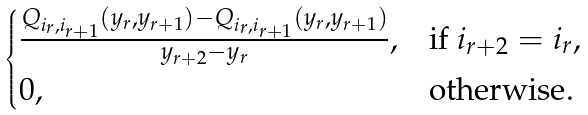Convert formula to latex. <formula><loc_0><loc_0><loc_500><loc_500>\begin{cases} \frac { Q _ { i _ { r } , i _ { r + 1 } } ( y _ { r } , y _ { r + 1 } ) - Q _ { i _ { r } , i _ { r + 1 } } ( y _ { r } , y _ { r + 1 } ) } { y _ { r + 2 } - y _ { r } } , & \text {if } i _ { r + 2 } = i _ { r } , \\ 0 , & \text {otherwise} . \end{cases}</formula> 